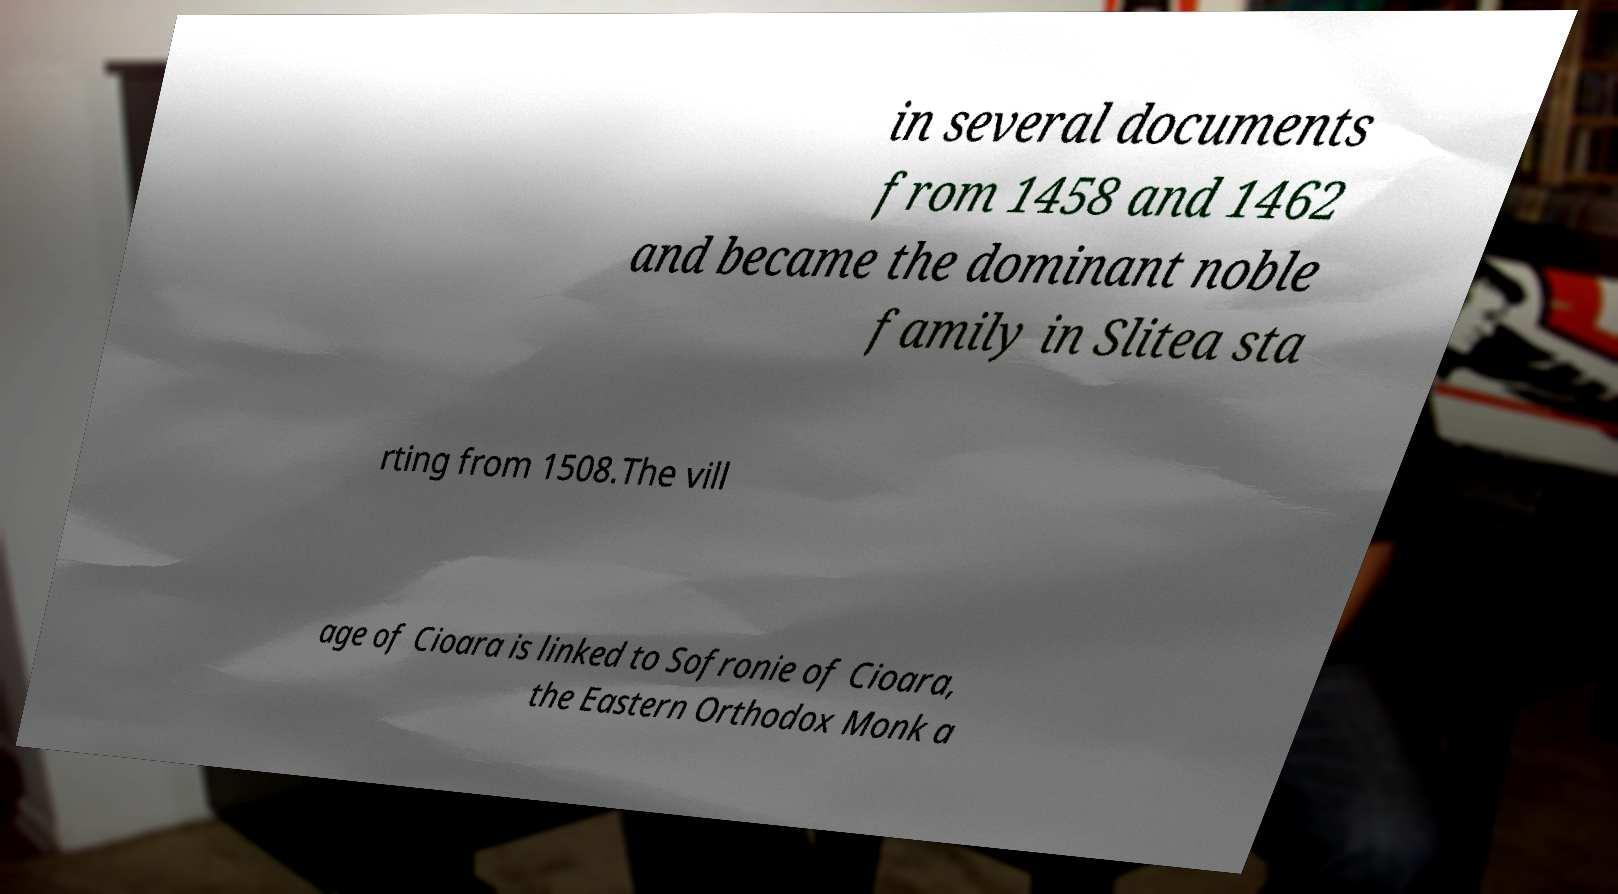For documentation purposes, I need the text within this image transcribed. Could you provide that? in several documents from 1458 and 1462 and became the dominant noble family in Slitea sta rting from 1508.The vill age of Cioara is linked to Sofronie of Cioara, the Eastern Orthodox Monk a 